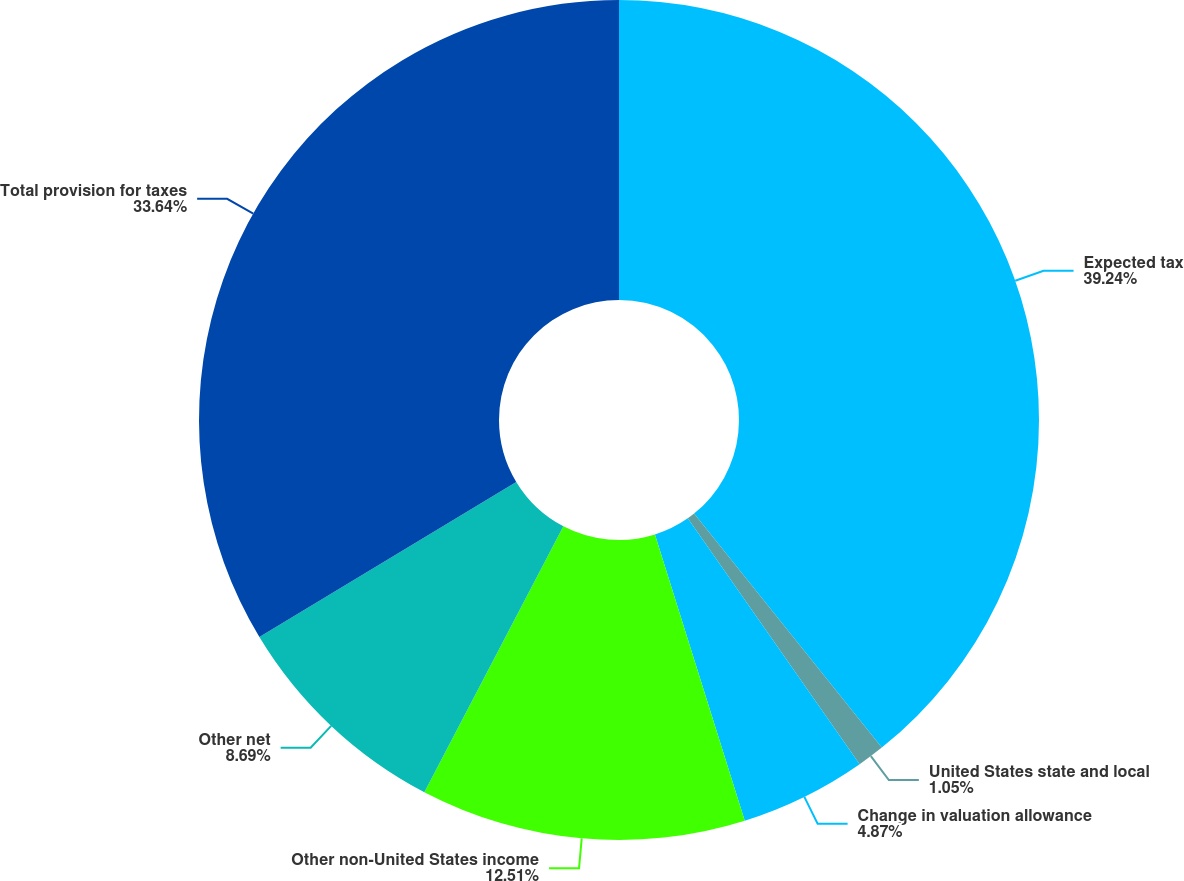Convert chart to OTSL. <chart><loc_0><loc_0><loc_500><loc_500><pie_chart><fcel>Expected tax<fcel>United States state and local<fcel>Change in valuation allowance<fcel>Other non-United States income<fcel>Other net<fcel>Total provision for taxes<nl><fcel>39.24%<fcel>1.05%<fcel>4.87%<fcel>12.51%<fcel>8.69%<fcel>33.64%<nl></chart> 